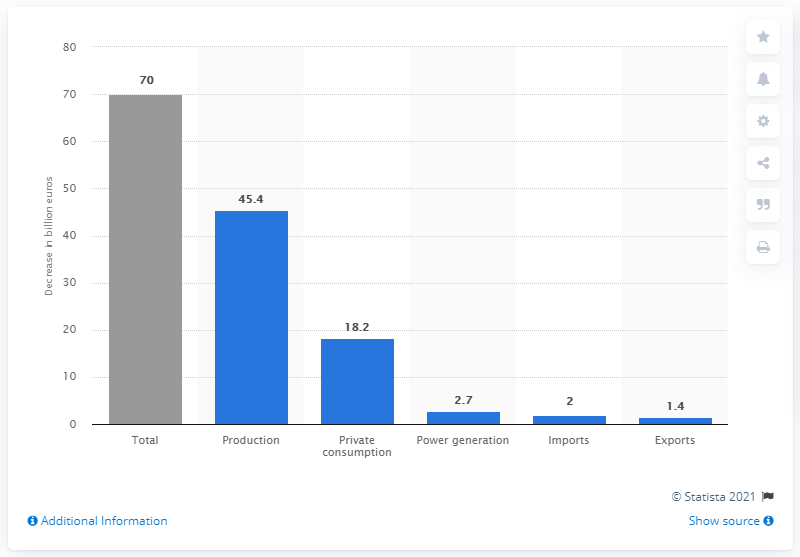Point out several critical features in this image. Japan's natural disaster resulted in a significant decrease in production, with a recorded decline of 45.4%. 